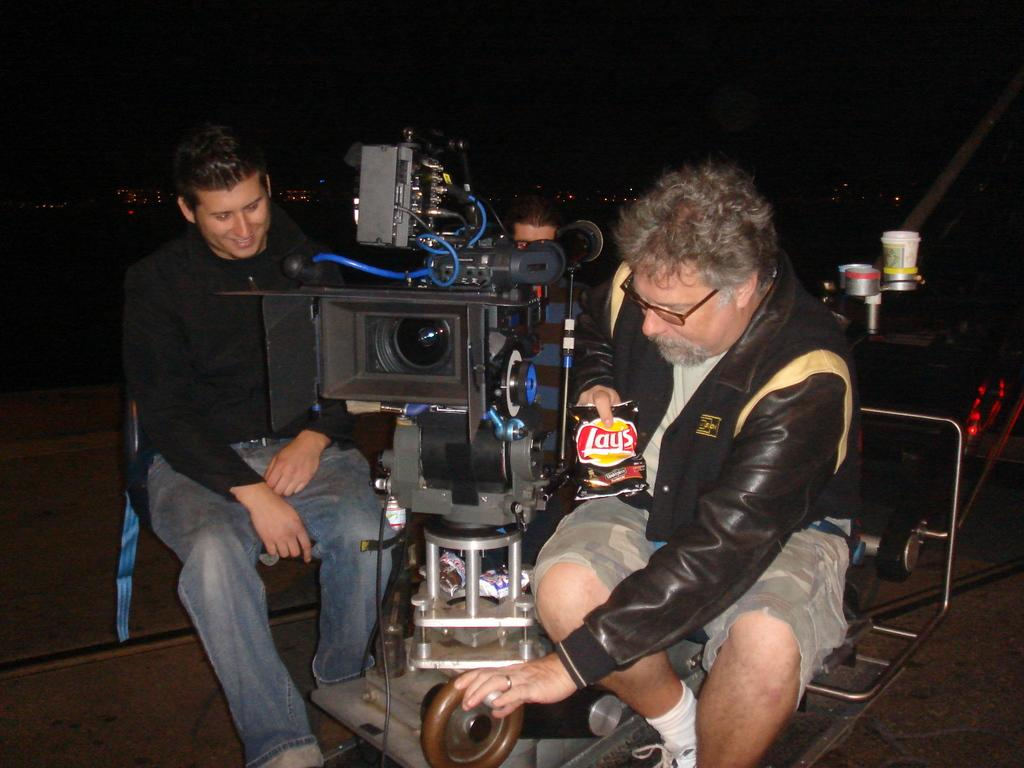What are the persons in the image doing? The persons in the image are sitting on chairs. What object is present between the persons? There is a camera between the persons. How would you describe the lighting in the image? The background of the image is dark. Can you see a kite flying in the image? There is no kite present in the image. Is there a slope visible in the image? There is no slope visible in the image. 